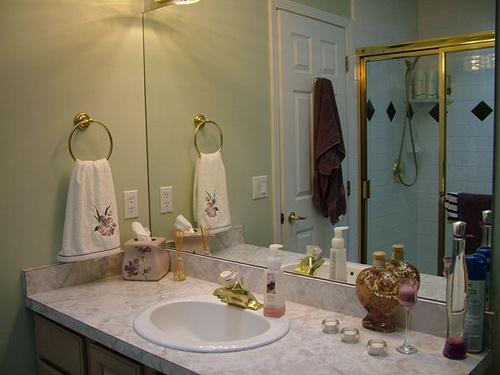Describe the objects in this image and their specific colors. I can see sink in olive, darkgray, and lightgray tones, bottle in olive, maroon, black, and gray tones, bottle in olive, gray, black, and darkgreen tones, and bottle in olive, darkgray, brown, and gray tones in this image. 